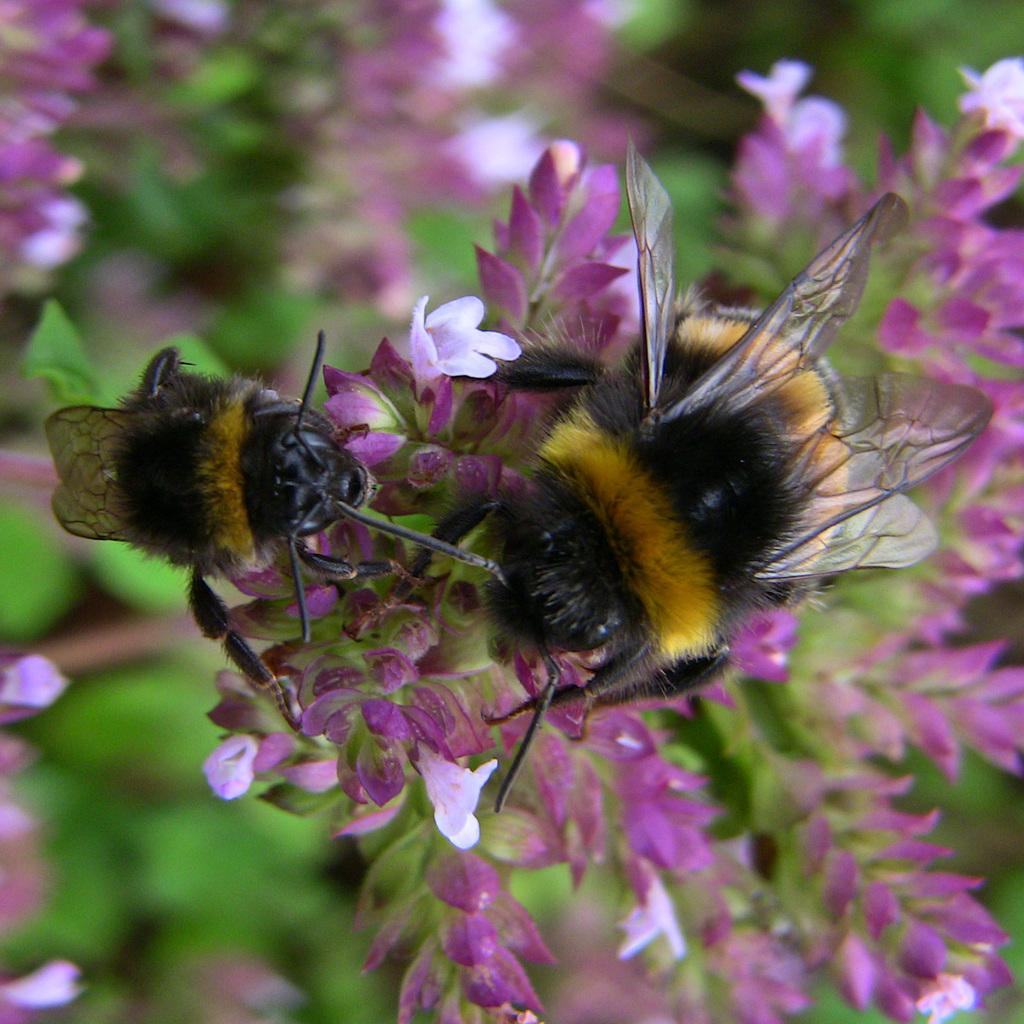What type of insects can be seen in the image? There are bees on the flowers in the image. What can be seen in the background of the image? There are leaves and flowers in the background of the image. What type of iron object is present in the image? There is no iron object present in the image; it features bees on flowers and leaves and flowers in the background. 